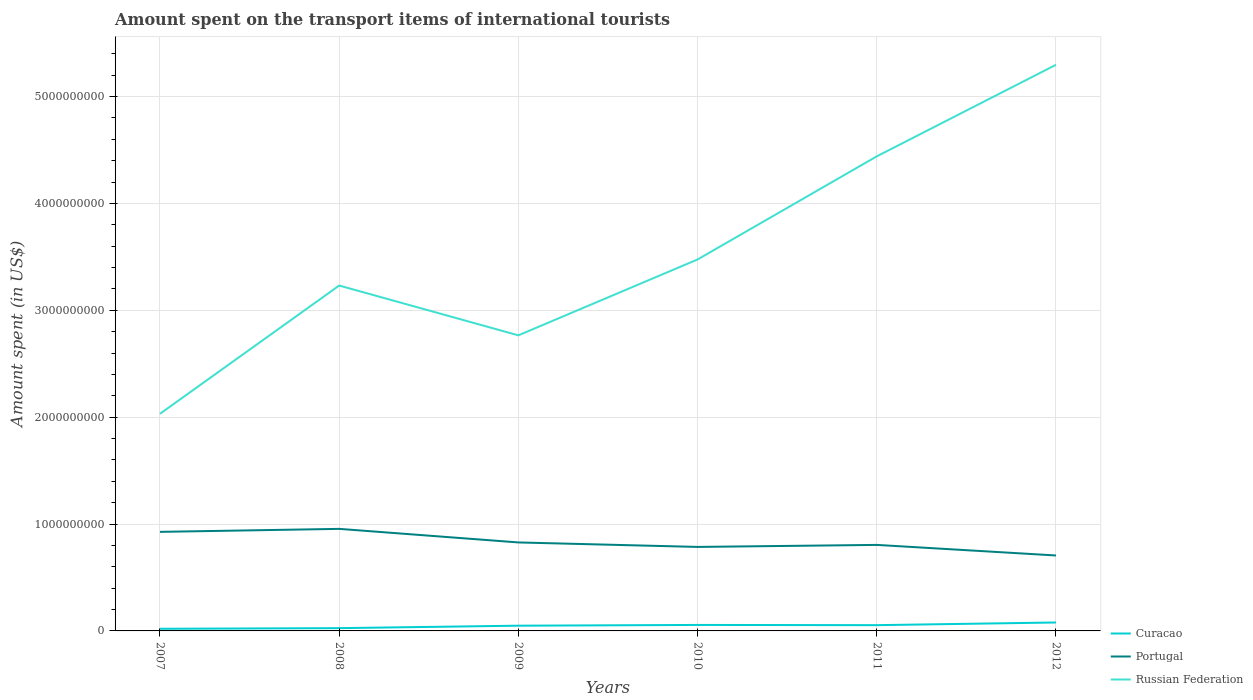Does the line corresponding to Russian Federation intersect with the line corresponding to Portugal?
Keep it short and to the point. No. Is the number of lines equal to the number of legend labels?
Offer a terse response. Yes. Across all years, what is the maximum amount spent on the transport items of international tourists in Russian Federation?
Offer a terse response. 2.03e+09. In which year was the amount spent on the transport items of international tourists in Portugal maximum?
Your answer should be compact. 2012. What is the total amount spent on the transport items of international tourists in Russian Federation in the graph?
Make the answer very short. -8.57e+08. What is the difference between the highest and the second highest amount spent on the transport items of international tourists in Russian Federation?
Make the answer very short. 3.27e+09. What is the difference between the highest and the lowest amount spent on the transport items of international tourists in Portugal?
Give a very brief answer. 2. How many lines are there?
Give a very brief answer. 3. What is the difference between two consecutive major ticks on the Y-axis?
Ensure brevity in your answer.  1.00e+09. Does the graph contain any zero values?
Your answer should be very brief. No. Does the graph contain grids?
Offer a terse response. Yes. Where does the legend appear in the graph?
Your answer should be very brief. Bottom right. How are the legend labels stacked?
Provide a short and direct response. Vertical. What is the title of the graph?
Offer a very short reply. Amount spent on the transport items of international tourists. What is the label or title of the Y-axis?
Make the answer very short. Amount spent (in US$). What is the Amount spent (in US$) of Portugal in 2007?
Provide a short and direct response. 9.27e+08. What is the Amount spent (in US$) of Russian Federation in 2007?
Your answer should be very brief. 2.03e+09. What is the Amount spent (in US$) in Curacao in 2008?
Make the answer very short. 2.60e+07. What is the Amount spent (in US$) of Portugal in 2008?
Your response must be concise. 9.55e+08. What is the Amount spent (in US$) in Russian Federation in 2008?
Offer a terse response. 3.23e+09. What is the Amount spent (in US$) of Curacao in 2009?
Your answer should be compact. 4.90e+07. What is the Amount spent (in US$) of Portugal in 2009?
Your answer should be compact. 8.28e+08. What is the Amount spent (in US$) of Russian Federation in 2009?
Make the answer very short. 2.77e+09. What is the Amount spent (in US$) of Curacao in 2010?
Provide a succinct answer. 5.60e+07. What is the Amount spent (in US$) of Portugal in 2010?
Offer a very short reply. 7.86e+08. What is the Amount spent (in US$) of Russian Federation in 2010?
Keep it short and to the point. 3.48e+09. What is the Amount spent (in US$) of Curacao in 2011?
Keep it short and to the point. 5.40e+07. What is the Amount spent (in US$) in Portugal in 2011?
Your response must be concise. 8.05e+08. What is the Amount spent (in US$) in Russian Federation in 2011?
Your answer should be very brief. 4.44e+09. What is the Amount spent (in US$) of Curacao in 2012?
Your response must be concise. 7.90e+07. What is the Amount spent (in US$) of Portugal in 2012?
Your answer should be compact. 7.06e+08. What is the Amount spent (in US$) in Russian Federation in 2012?
Make the answer very short. 5.30e+09. Across all years, what is the maximum Amount spent (in US$) of Curacao?
Provide a short and direct response. 7.90e+07. Across all years, what is the maximum Amount spent (in US$) in Portugal?
Make the answer very short. 9.55e+08. Across all years, what is the maximum Amount spent (in US$) in Russian Federation?
Offer a very short reply. 5.30e+09. Across all years, what is the minimum Amount spent (in US$) in Curacao?
Ensure brevity in your answer.  2.00e+07. Across all years, what is the minimum Amount spent (in US$) in Portugal?
Offer a terse response. 7.06e+08. Across all years, what is the minimum Amount spent (in US$) of Russian Federation?
Offer a terse response. 2.03e+09. What is the total Amount spent (in US$) in Curacao in the graph?
Provide a short and direct response. 2.84e+08. What is the total Amount spent (in US$) in Portugal in the graph?
Ensure brevity in your answer.  5.01e+09. What is the total Amount spent (in US$) of Russian Federation in the graph?
Your answer should be compact. 2.12e+1. What is the difference between the Amount spent (in US$) of Curacao in 2007 and that in 2008?
Provide a short and direct response. -6.00e+06. What is the difference between the Amount spent (in US$) of Portugal in 2007 and that in 2008?
Your answer should be very brief. -2.80e+07. What is the difference between the Amount spent (in US$) in Russian Federation in 2007 and that in 2008?
Your answer should be compact. -1.20e+09. What is the difference between the Amount spent (in US$) of Curacao in 2007 and that in 2009?
Ensure brevity in your answer.  -2.90e+07. What is the difference between the Amount spent (in US$) of Portugal in 2007 and that in 2009?
Offer a very short reply. 9.90e+07. What is the difference between the Amount spent (in US$) of Russian Federation in 2007 and that in 2009?
Your response must be concise. -7.34e+08. What is the difference between the Amount spent (in US$) of Curacao in 2007 and that in 2010?
Provide a succinct answer. -3.60e+07. What is the difference between the Amount spent (in US$) in Portugal in 2007 and that in 2010?
Make the answer very short. 1.41e+08. What is the difference between the Amount spent (in US$) in Russian Federation in 2007 and that in 2010?
Make the answer very short. -1.44e+09. What is the difference between the Amount spent (in US$) of Curacao in 2007 and that in 2011?
Your answer should be compact. -3.40e+07. What is the difference between the Amount spent (in US$) in Portugal in 2007 and that in 2011?
Provide a succinct answer. 1.22e+08. What is the difference between the Amount spent (in US$) of Russian Federation in 2007 and that in 2011?
Offer a very short reply. -2.41e+09. What is the difference between the Amount spent (in US$) of Curacao in 2007 and that in 2012?
Give a very brief answer. -5.90e+07. What is the difference between the Amount spent (in US$) in Portugal in 2007 and that in 2012?
Your answer should be compact. 2.21e+08. What is the difference between the Amount spent (in US$) of Russian Federation in 2007 and that in 2012?
Your answer should be very brief. -3.27e+09. What is the difference between the Amount spent (in US$) of Curacao in 2008 and that in 2009?
Keep it short and to the point. -2.30e+07. What is the difference between the Amount spent (in US$) in Portugal in 2008 and that in 2009?
Give a very brief answer. 1.27e+08. What is the difference between the Amount spent (in US$) in Russian Federation in 2008 and that in 2009?
Your answer should be very brief. 4.66e+08. What is the difference between the Amount spent (in US$) of Curacao in 2008 and that in 2010?
Provide a succinct answer. -3.00e+07. What is the difference between the Amount spent (in US$) of Portugal in 2008 and that in 2010?
Offer a very short reply. 1.69e+08. What is the difference between the Amount spent (in US$) in Russian Federation in 2008 and that in 2010?
Offer a terse response. -2.44e+08. What is the difference between the Amount spent (in US$) of Curacao in 2008 and that in 2011?
Your response must be concise. -2.80e+07. What is the difference between the Amount spent (in US$) in Portugal in 2008 and that in 2011?
Provide a short and direct response. 1.50e+08. What is the difference between the Amount spent (in US$) in Russian Federation in 2008 and that in 2011?
Ensure brevity in your answer.  -1.21e+09. What is the difference between the Amount spent (in US$) in Curacao in 2008 and that in 2012?
Keep it short and to the point. -5.30e+07. What is the difference between the Amount spent (in US$) in Portugal in 2008 and that in 2012?
Your answer should be very brief. 2.49e+08. What is the difference between the Amount spent (in US$) of Russian Federation in 2008 and that in 2012?
Offer a terse response. -2.07e+09. What is the difference between the Amount spent (in US$) in Curacao in 2009 and that in 2010?
Your response must be concise. -7.00e+06. What is the difference between the Amount spent (in US$) of Portugal in 2009 and that in 2010?
Make the answer very short. 4.20e+07. What is the difference between the Amount spent (in US$) of Russian Federation in 2009 and that in 2010?
Your answer should be very brief. -7.10e+08. What is the difference between the Amount spent (in US$) in Curacao in 2009 and that in 2011?
Provide a short and direct response. -5.00e+06. What is the difference between the Amount spent (in US$) in Portugal in 2009 and that in 2011?
Keep it short and to the point. 2.30e+07. What is the difference between the Amount spent (in US$) in Russian Federation in 2009 and that in 2011?
Make the answer very short. -1.68e+09. What is the difference between the Amount spent (in US$) of Curacao in 2009 and that in 2012?
Offer a very short reply. -3.00e+07. What is the difference between the Amount spent (in US$) of Portugal in 2009 and that in 2012?
Give a very brief answer. 1.22e+08. What is the difference between the Amount spent (in US$) of Russian Federation in 2009 and that in 2012?
Offer a very short reply. -2.53e+09. What is the difference between the Amount spent (in US$) of Curacao in 2010 and that in 2011?
Ensure brevity in your answer.  2.00e+06. What is the difference between the Amount spent (in US$) in Portugal in 2010 and that in 2011?
Ensure brevity in your answer.  -1.90e+07. What is the difference between the Amount spent (in US$) of Russian Federation in 2010 and that in 2011?
Your answer should be compact. -9.65e+08. What is the difference between the Amount spent (in US$) in Curacao in 2010 and that in 2012?
Offer a terse response. -2.30e+07. What is the difference between the Amount spent (in US$) of Portugal in 2010 and that in 2012?
Your response must be concise. 8.00e+07. What is the difference between the Amount spent (in US$) in Russian Federation in 2010 and that in 2012?
Your answer should be compact. -1.82e+09. What is the difference between the Amount spent (in US$) in Curacao in 2011 and that in 2012?
Provide a short and direct response. -2.50e+07. What is the difference between the Amount spent (in US$) of Portugal in 2011 and that in 2012?
Offer a terse response. 9.90e+07. What is the difference between the Amount spent (in US$) of Russian Federation in 2011 and that in 2012?
Provide a short and direct response. -8.57e+08. What is the difference between the Amount spent (in US$) in Curacao in 2007 and the Amount spent (in US$) in Portugal in 2008?
Your response must be concise. -9.35e+08. What is the difference between the Amount spent (in US$) of Curacao in 2007 and the Amount spent (in US$) of Russian Federation in 2008?
Ensure brevity in your answer.  -3.21e+09. What is the difference between the Amount spent (in US$) of Portugal in 2007 and the Amount spent (in US$) of Russian Federation in 2008?
Keep it short and to the point. -2.30e+09. What is the difference between the Amount spent (in US$) in Curacao in 2007 and the Amount spent (in US$) in Portugal in 2009?
Your response must be concise. -8.08e+08. What is the difference between the Amount spent (in US$) in Curacao in 2007 and the Amount spent (in US$) in Russian Federation in 2009?
Ensure brevity in your answer.  -2.75e+09. What is the difference between the Amount spent (in US$) in Portugal in 2007 and the Amount spent (in US$) in Russian Federation in 2009?
Make the answer very short. -1.84e+09. What is the difference between the Amount spent (in US$) in Curacao in 2007 and the Amount spent (in US$) in Portugal in 2010?
Give a very brief answer. -7.66e+08. What is the difference between the Amount spent (in US$) in Curacao in 2007 and the Amount spent (in US$) in Russian Federation in 2010?
Your answer should be very brief. -3.46e+09. What is the difference between the Amount spent (in US$) in Portugal in 2007 and the Amount spent (in US$) in Russian Federation in 2010?
Your answer should be very brief. -2.55e+09. What is the difference between the Amount spent (in US$) of Curacao in 2007 and the Amount spent (in US$) of Portugal in 2011?
Keep it short and to the point. -7.85e+08. What is the difference between the Amount spent (in US$) in Curacao in 2007 and the Amount spent (in US$) in Russian Federation in 2011?
Your answer should be very brief. -4.42e+09. What is the difference between the Amount spent (in US$) in Portugal in 2007 and the Amount spent (in US$) in Russian Federation in 2011?
Offer a terse response. -3.51e+09. What is the difference between the Amount spent (in US$) of Curacao in 2007 and the Amount spent (in US$) of Portugal in 2012?
Provide a succinct answer. -6.86e+08. What is the difference between the Amount spent (in US$) of Curacao in 2007 and the Amount spent (in US$) of Russian Federation in 2012?
Offer a very short reply. -5.28e+09. What is the difference between the Amount spent (in US$) in Portugal in 2007 and the Amount spent (in US$) in Russian Federation in 2012?
Your answer should be compact. -4.37e+09. What is the difference between the Amount spent (in US$) in Curacao in 2008 and the Amount spent (in US$) in Portugal in 2009?
Provide a succinct answer. -8.02e+08. What is the difference between the Amount spent (in US$) of Curacao in 2008 and the Amount spent (in US$) of Russian Federation in 2009?
Offer a terse response. -2.74e+09. What is the difference between the Amount spent (in US$) in Portugal in 2008 and the Amount spent (in US$) in Russian Federation in 2009?
Keep it short and to the point. -1.81e+09. What is the difference between the Amount spent (in US$) of Curacao in 2008 and the Amount spent (in US$) of Portugal in 2010?
Give a very brief answer. -7.60e+08. What is the difference between the Amount spent (in US$) in Curacao in 2008 and the Amount spent (in US$) in Russian Federation in 2010?
Provide a short and direct response. -3.45e+09. What is the difference between the Amount spent (in US$) in Portugal in 2008 and the Amount spent (in US$) in Russian Federation in 2010?
Provide a short and direct response. -2.52e+09. What is the difference between the Amount spent (in US$) in Curacao in 2008 and the Amount spent (in US$) in Portugal in 2011?
Your answer should be compact. -7.79e+08. What is the difference between the Amount spent (in US$) of Curacao in 2008 and the Amount spent (in US$) of Russian Federation in 2011?
Offer a terse response. -4.42e+09. What is the difference between the Amount spent (in US$) in Portugal in 2008 and the Amount spent (in US$) in Russian Federation in 2011?
Your answer should be compact. -3.49e+09. What is the difference between the Amount spent (in US$) in Curacao in 2008 and the Amount spent (in US$) in Portugal in 2012?
Your response must be concise. -6.80e+08. What is the difference between the Amount spent (in US$) in Curacao in 2008 and the Amount spent (in US$) in Russian Federation in 2012?
Your answer should be very brief. -5.27e+09. What is the difference between the Amount spent (in US$) of Portugal in 2008 and the Amount spent (in US$) of Russian Federation in 2012?
Provide a succinct answer. -4.34e+09. What is the difference between the Amount spent (in US$) of Curacao in 2009 and the Amount spent (in US$) of Portugal in 2010?
Offer a very short reply. -7.37e+08. What is the difference between the Amount spent (in US$) in Curacao in 2009 and the Amount spent (in US$) in Russian Federation in 2010?
Keep it short and to the point. -3.43e+09. What is the difference between the Amount spent (in US$) in Portugal in 2009 and the Amount spent (in US$) in Russian Federation in 2010?
Offer a terse response. -2.65e+09. What is the difference between the Amount spent (in US$) in Curacao in 2009 and the Amount spent (in US$) in Portugal in 2011?
Give a very brief answer. -7.56e+08. What is the difference between the Amount spent (in US$) in Curacao in 2009 and the Amount spent (in US$) in Russian Federation in 2011?
Offer a very short reply. -4.39e+09. What is the difference between the Amount spent (in US$) in Portugal in 2009 and the Amount spent (in US$) in Russian Federation in 2011?
Provide a succinct answer. -3.61e+09. What is the difference between the Amount spent (in US$) in Curacao in 2009 and the Amount spent (in US$) in Portugal in 2012?
Give a very brief answer. -6.57e+08. What is the difference between the Amount spent (in US$) in Curacao in 2009 and the Amount spent (in US$) in Russian Federation in 2012?
Make the answer very short. -5.25e+09. What is the difference between the Amount spent (in US$) in Portugal in 2009 and the Amount spent (in US$) in Russian Federation in 2012?
Ensure brevity in your answer.  -4.47e+09. What is the difference between the Amount spent (in US$) of Curacao in 2010 and the Amount spent (in US$) of Portugal in 2011?
Provide a short and direct response. -7.49e+08. What is the difference between the Amount spent (in US$) in Curacao in 2010 and the Amount spent (in US$) in Russian Federation in 2011?
Offer a terse response. -4.38e+09. What is the difference between the Amount spent (in US$) of Portugal in 2010 and the Amount spent (in US$) of Russian Federation in 2011?
Make the answer very short. -3.66e+09. What is the difference between the Amount spent (in US$) of Curacao in 2010 and the Amount spent (in US$) of Portugal in 2012?
Provide a succinct answer. -6.50e+08. What is the difference between the Amount spent (in US$) in Curacao in 2010 and the Amount spent (in US$) in Russian Federation in 2012?
Your answer should be compact. -5.24e+09. What is the difference between the Amount spent (in US$) in Portugal in 2010 and the Amount spent (in US$) in Russian Federation in 2012?
Your answer should be compact. -4.51e+09. What is the difference between the Amount spent (in US$) in Curacao in 2011 and the Amount spent (in US$) in Portugal in 2012?
Make the answer very short. -6.52e+08. What is the difference between the Amount spent (in US$) of Curacao in 2011 and the Amount spent (in US$) of Russian Federation in 2012?
Keep it short and to the point. -5.24e+09. What is the difference between the Amount spent (in US$) in Portugal in 2011 and the Amount spent (in US$) in Russian Federation in 2012?
Offer a terse response. -4.49e+09. What is the average Amount spent (in US$) in Curacao per year?
Your answer should be very brief. 4.73e+07. What is the average Amount spent (in US$) of Portugal per year?
Your answer should be compact. 8.34e+08. What is the average Amount spent (in US$) of Russian Federation per year?
Your answer should be very brief. 3.54e+09. In the year 2007, what is the difference between the Amount spent (in US$) of Curacao and Amount spent (in US$) of Portugal?
Your response must be concise. -9.07e+08. In the year 2007, what is the difference between the Amount spent (in US$) of Curacao and Amount spent (in US$) of Russian Federation?
Make the answer very short. -2.01e+09. In the year 2007, what is the difference between the Amount spent (in US$) of Portugal and Amount spent (in US$) of Russian Federation?
Give a very brief answer. -1.10e+09. In the year 2008, what is the difference between the Amount spent (in US$) of Curacao and Amount spent (in US$) of Portugal?
Your answer should be compact. -9.29e+08. In the year 2008, what is the difference between the Amount spent (in US$) of Curacao and Amount spent (in US$) of Russian Federation?
Provide a succinct answer. -3.21e+09. In the year 2008, what is the difference between the Amount spent (in US$) of Portugal and Amount spent (in US$) of Russian Federation?
Provide a short and direct response. -2.28e+09. In the year 2009, what is the difference between the Amount spent (in US$) in Curacao and Amount spent (in US$) in Portugal?
Your answer should be very brief. -7.79e+08. In the year 2009, what is the difference between the Amount spent (in US$) in Curacao and Amount spent (in US$) in Russian Federation?
Provide a succinct answer. -2.72e+09. In the year 2009, what is the difference between the Amount spent (in US$) of Portugal and Amount spent (in US$) of Russian Federation?
Provide a succinct answer. -1.94e+09. In the year 2010, what is the difference between the Amount spent (in US$) in Curacao and Amount spent (in US$) in Portugal?
Give a very brief answer. -7.30e+08. In the year 2010, what is the difference between the Amount spent (in US$) of Curacao and Amount spent (in US$) of Russian Federation?
Keep it short and to the point. -3.42e+09. In the year 2010, what is the difference between the Amount spent (in US$) in Portugal and Amount spent (in US$) in Russian Federation?
Your answer should be very brief. -2.69e+09. In the year 2011, what is the difference between the Amount spent (in US$) in Curacao and Amount spent (in US$) in Portugal?
Keep it short and to the point. -7.51e+08. In the year 2011, what is the difference between the Amount spent (in US$) in Curacao and Amount spent (in US$) in Russian Federation?
Give a very brief answer. -4.39e+09. In the year 2011, what is the difference between the Amount spent (in US$) in Portugal and Amount spent (in US$) in Russian Federation?
Your answer should be very brief. -3.64e+09. In the year 2012, what is the difference between the Amount spent (in US$) of Curacao and Amount spent (in US$) of Portugal?
Offer a very short reply. -6.27e+08. In the year 2012, what is the difference between the Amount spent (in US$) in Curacao and Amount spent (in US$) in Russian Federation?
Provide a succinct answer. -5.22e+09. In the year 2012, what is the difference between the Amount spent (in US$) of Portugal and Amount spent (in US$) of Russian Federation?
Make the answer very short. -4.59e+09. What is the ratio of the Amount spent (in US$) of Curacao in 2007 to that in 2008?
Make the answer very short. 0.77. What is the ratio of the Amount spent (in US$) in Portugal in 2007 to that in 2008?
Keep it short and to the point. 0.97. What is the ratio of the Amount spent (in US$) in Russian Federation in 2007 to that in 2008?
Ensure brevity in your answer.  0.63. What is the ratio of the Amount spent (in US$) of Curacao in 2007 to that in 2009?
Ensure brevity in your answer.  0.41. What is the ratio of the Amount spent (in US$) in Portugal in 2007 to that in 2009?
Offer a very short reply. 1.12. What is the ratio of the Amount spent (in US$) in Russian Federation in 2007 to that in 2009?
Ensure brevity in your answer.  0.73. What is the ratio of the Amount spent (in US$) in Curacao in 2007 to that in 2010?
Your answer should be very brief. 0.36. What is the ratio of the Amount spent (in US$) of Portugal in 2007 to that in 2010?
Make the answer very short. 1.18. What is the ratio of the Amount spent (in US$) of Russian Federation in 2007 to that in 2010?
Offer a terse response. 0.58. What is the ratio of the Amount spent (in US$) in Curacao in 2007 to that in 2011?
Your answer should be compact. 0.37. What is the ratio of the Amount spent (in US$) in Portugal in 2007 to that in 2011?
Offer a very short reply. 1.15. What is the ratio of the Amount spent (in US$) of Russian Federation in 2007 to that in 2011?
Make the answer very short. 0.46. What is the ratio of the Amount spent (in US$) of Curacao in 2007 to that in 2012?
Ensure brevity in your answer.  0.25. What is the ratio of the Amount spent (in US$) of Portugal in 2007 to that in 2012?
Provide a succinct answer. 1.31. What is the ratio of the Amount spent (in US$) in Russian Federation in 2007 to that in 2012?
Keep it short and to the point. 0.38. What is the ratio of the Amount spent (in US$) in Curacao in 2008 to that in 2009?
Ensure brevity in your answer.  0.53. What is the ratio of the Amount spent (in US$) of Portugal in 2008 to that in 2009?
Give a very brief answer. 1.15. What is the ratio of the Amount spent (in US$) of Russian Federation in 2008 to that in 2009?
Give a very brief answer. 1.17. What is the ratio of the Amount spent (in US$) in Curacao in 2008 to that in 2010?
Offer a very short reply. 0.46. What is the ratio of the Amount spent (in US$) in Portugal in 2008 to that in 2010?
Provide a short and direct response. 1.22. What is the ratio of the Amount spent (in US$) in Russian Federation in 2008 to that in 2010?
Offer a very short reply. 0.93. What is the ratio of the Amount spent (in US$) in Curacao in 2008 to that in 2011?
Keep it short and to the point. 0.48. What is the ratio of the Amount spent (in US$) in Portugal in 2008 to that in 2011?
Ensure brevity in your answer.  1.19. What is the ratio of the Amount spent (in US$) in Russian Federation in 2008 to that in 2011?
Provide a short and direct response. 0.73. What is the ratio of the Amount spent (in US$) of Curacao in 2008 to that in 2012?
Your answer should be compact. 0.33. What is the ratio of the Amount spent (in US$) of Portugal in 2008 to that in 2012?
Ensure brevity in your answer.  1.35. What is the ratio of the Amount spent (in US$) of Russian Federation in 2008 to that in 2012?
Ensure brevity in your answer.  0.61. What is the ratio of the Amount spent (in US$) of Curacao in 2009 to that in 2010?
Make the answer very short. 0.88. What is the ratio of the Amount spent (in US$) in Portugal in 2009 to that in 2010?
Your response must be concise. 1.05. What is the ratio of the Amount spent (in US$) in Russian Federation in 2009 to that in 2010?
Keep it short and to the point. 0.8. What is the ratio of the Amount spent (in US$) in Curacao in 2009 to that in 2011?
Offer a terse response. 0.91. What is the ratio of the Amount spent (in US$) in Portugal in 2009 to that in 2011?
Your answer should be compact. 1.03. What is the ratio of the Amount spent (in US$) of Russian Federation in 2009 to that in 2011?
Give a very brief answer. 0.62. What is the ratio of the Amount spent (in US$) of Curacao in 2009 to that in 2012?
Your response must be concise. 0.62. What is the ratio of the Amount spent (in US$) of Portugal in 2009 to that in 2012?
Keep it short and to the point. 1.17. What is the ratio of the Amount spent (in US$) of Russian Federation in 2009 to that in 2012?
Your answer should be compact. 0.52. What is the ratio of the Amount spent (in US$) of Portugal in 2010 to that in 2011?
Provide a short and direct response. 0.98. What is the ratio of the Amount spent (in US$) of Russian Federation in 2010 to that in 2011?
Your answer should be compact. 0.78. What is the ratio of the Amount spent (in US$) in Curacao in 2010 to that in 2012?
Offer a terse response. 0.71. What is the ratio of the Amount spent (in US$) in Portugal in 2010 to that in 2012?
Make the answer very short. 1.11. What is the ratio of the Amount spent (in US$) in Russian Federation in 2010 to that in 2012?
Your answer should be very brief. 0.66. What is the ratio of the Amount spent (in US$) in Curacao in 2011 to that in 2012?
Your answer should be very brief. 0.68. What is the ratio of the Amount spent (in US$) of Portugal in 2011 to that in 2012?
Keep it short and to the point. 1.14. What is the ratio of the Amount spent (in US$) of Russian Federation in 2011 to that in 2012?
Your answer should be compact. 0.84. What is the difference between the highest and the second highest Amount spent (in US$) in Curacao?
Your answer should be very brief. 2.30e+07. What is the difference between the highest and the second highest Amount spent (in US$) of Portugal?
Your response must be concise. 2.80e+07. What is the difference between the highest and the second highest Amount spent (in US$) of Russian Federation?
Your response must be concise. 8.57e+08. What is the difference between the highest and the lowest Amount spent (in US$) in Curacao?
Your response must be concise. 5.90e+07. What is the difference between the highest and the lowest Amount spent (in US$) in Portugal?
Make the answer very short. 2.49e+08. What is the difference between the highest and the lowest Amount spent (in US$) in Russian Federation?
Provide a succinct answer. 3.27e+09. 